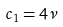<formula> <loc_0><loc_0><loc_500><loc_500>c _ { 1 } = 4 \nu</formula> 